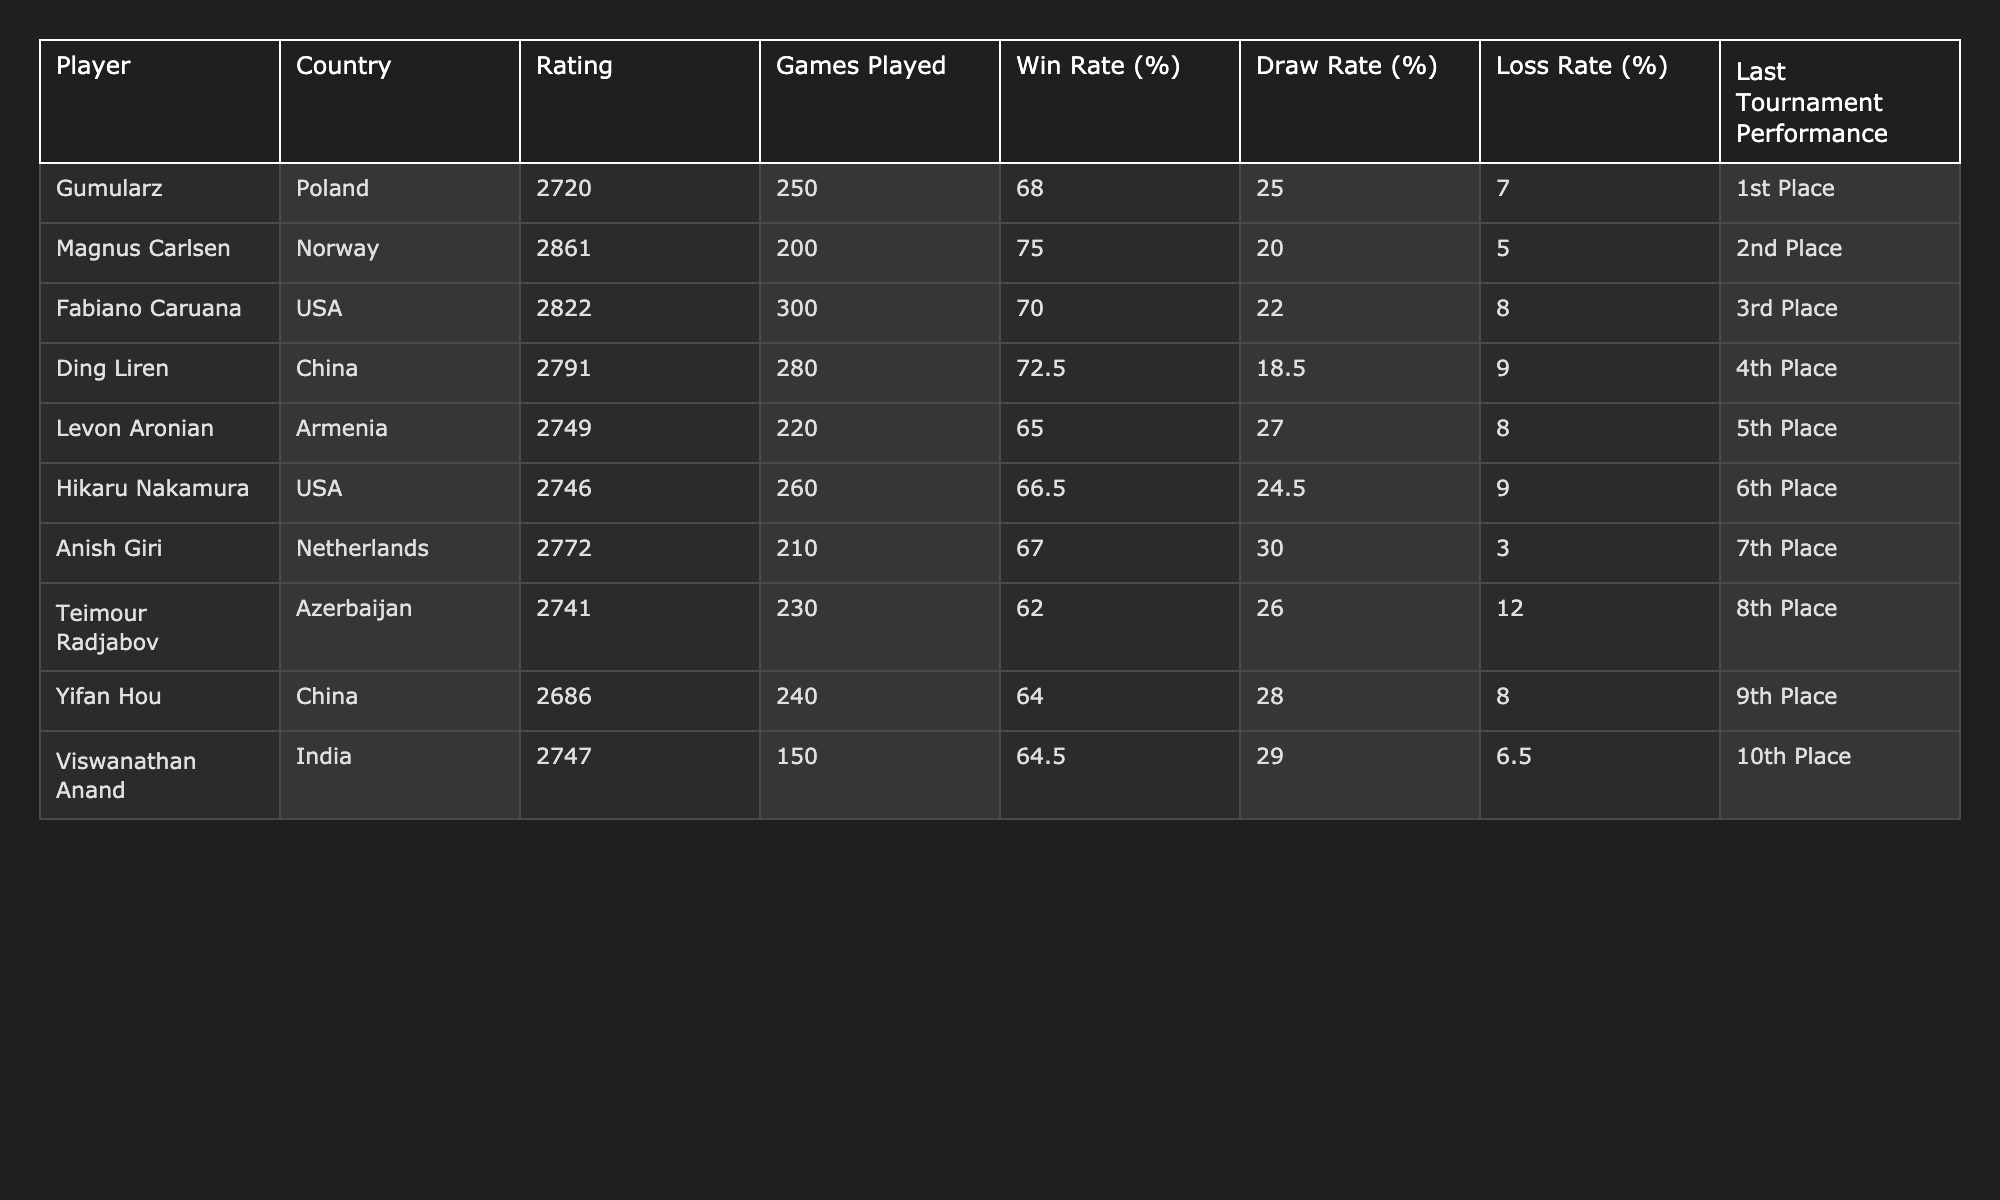What is Magnus Carlsen's win rate? According to the table, Magnus Carlsen has a win rate of 75.0%.
Answer: 75.0% Which player has the highest rating? The table shows that Magnus Carlsen has the highest rating of 2861 among all players listed.
Answer: Magnus Carlsen How many games did Ding Liren play? Ding Liren played a total of 280 games, as indicated in the table.
Answer: 280 What is the average draw rate of the players listed? To find the average draw rate, sum all the draw rates (25.0 + 20.0 + 22.0 + 18.5 + 27.0 + 24.5 + 30.0 + 26.0 + 28.0 + 29.0 =  30.0) and divide by the number of players (10): 250.0 / 10 = 25.0.
Answer: 25.0 Is Yifan Hou's loss rate higher than Levon Aronian's? Yifan Hou's loss rate is 8.0%, while Levon Aronian's is 8.0%. Since these values are equal, the answer is false.
Answer: False Which player has the lowest win rate? Analyzing the win rates, Teimour Radjabov has the lowest win rate at 62.0%.
Answer: Teimour Radjabov What is the difference in rating between Gumularz and Fabiano Caruana? By subtracting Gumularz's rating (2720) from Fabiano Caruana's rating (2822), we get 2822 - 2720 = 102.
Answer: 102 Which player had the best performance in their last tournament? According to the table, Gumularz achieved 1st place in his last tournament, which is the highest performance listed.
Answer: Gumularz What is the total number of games played by all players combined? The total number of games played is the sum of all individual games: 250 + 200 + 300 + 280 + 220 + 260 + 210 + 230 + 240 + 150 = 2390.
Answer: 2390 Did any player have a loss rate of less than 5%? Upon reviewing the loss rates in the table, the lowest loss rate is 6.5% (Viswanathan Anand), so no players have a loss rate of less than 5%.
Answer: No 